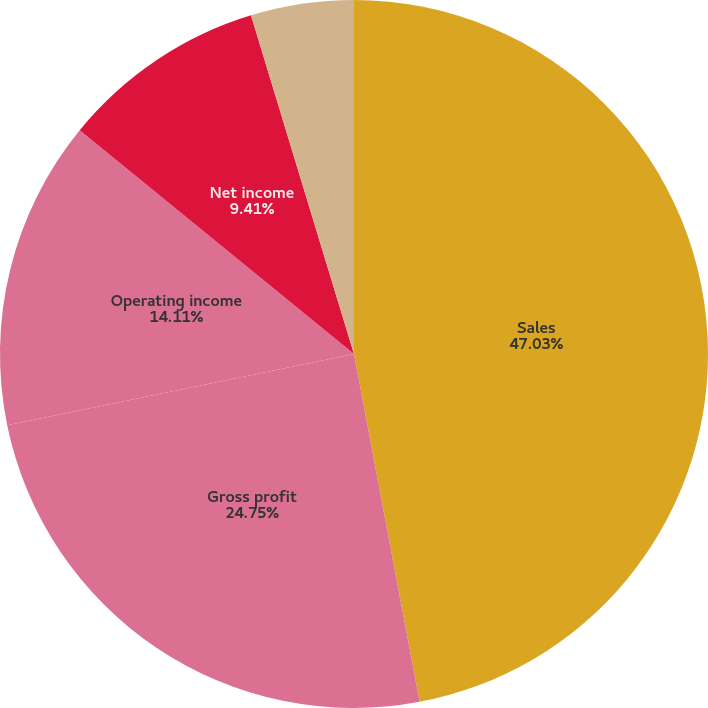Convert chart to OTSL. <chart><loc_0><loc_0><loc_500><loc_500><pie_chart><fcel>Sales<fcel>Gross profit<fcel>Operating income<fcel>Net income<fcel>Earnings per share - basic (1)<fcel>Earnings per share - assuming<nl><fcel>47.03%<fcel>24.75%<fcel>14.11%<fcel>9.41%<fcel>4.7%<fcel>0.0%<nl></chart> 